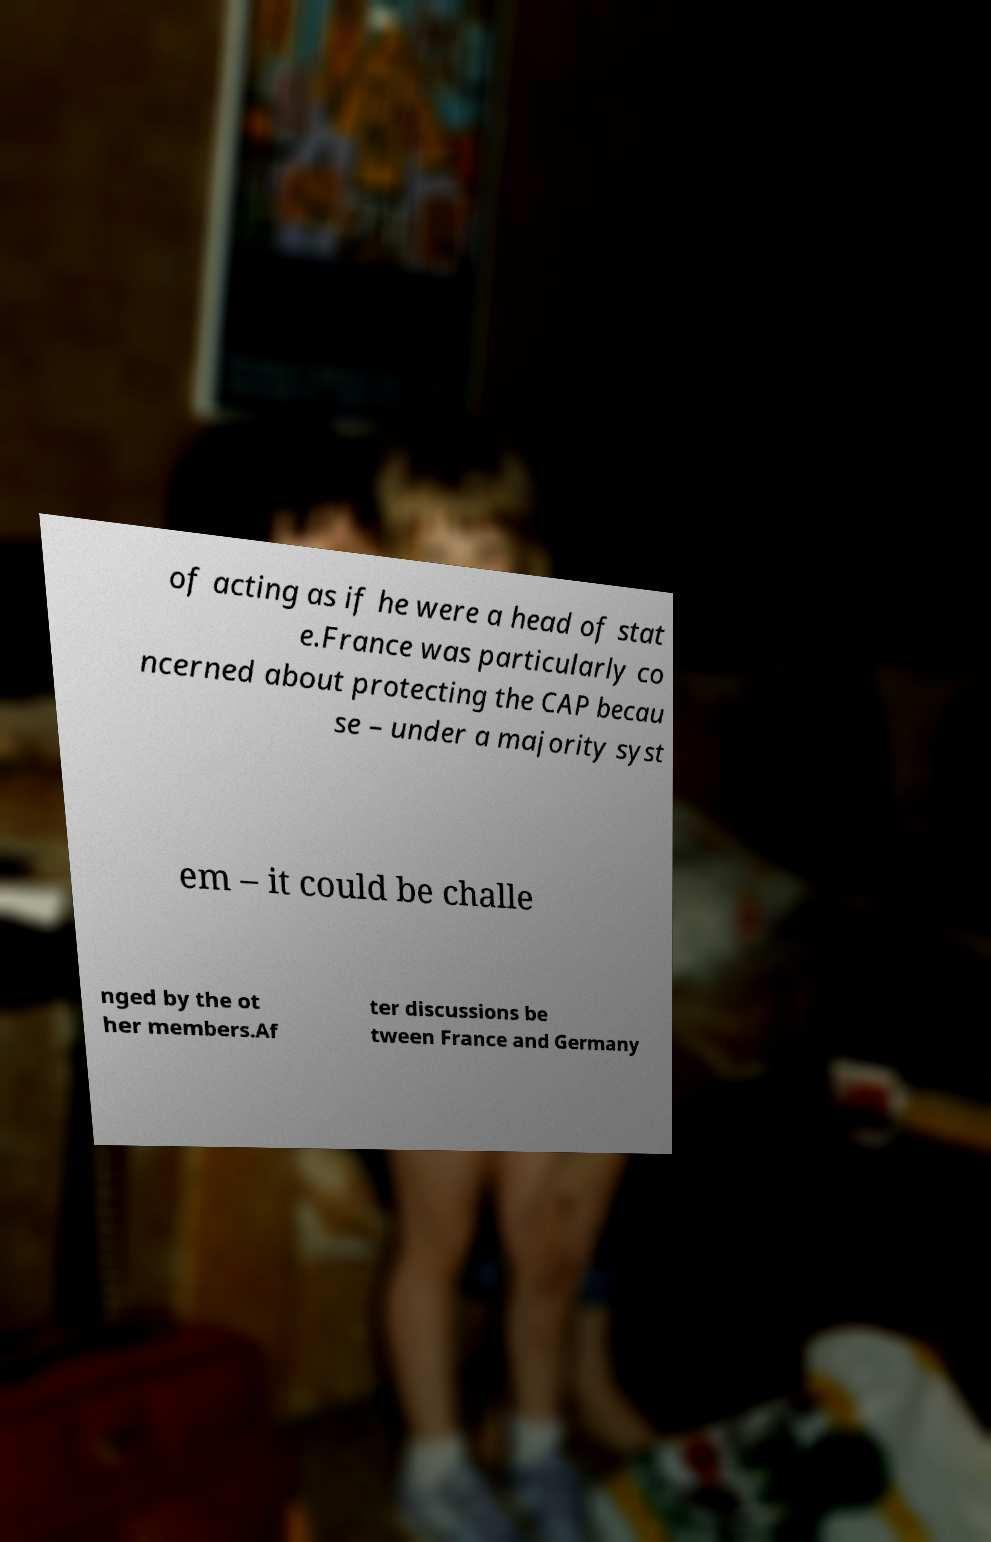Could you assist in decoding the text presented in this image and type it out clearly? of acting as if he were a head of stat e.France was particularly co ncerned about protecting the CAP becau se – under a majority syst em – it could be challe nged by the ot her members.Af ter discussions be tween France and Germany 